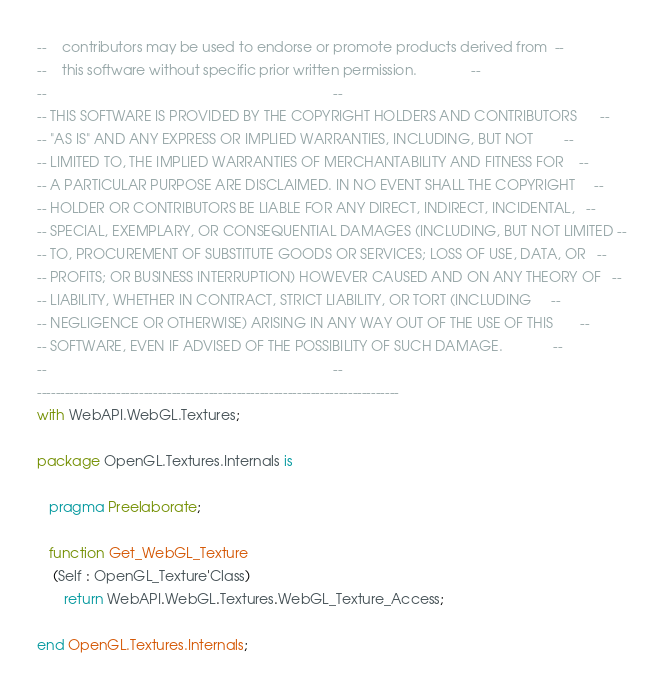Convert code to text. <code><loc_0><loc_0><loc_500><loc_500><_Ada_>--    contributors may be used to endorse or promote products derived from  --
--    this software without specific prior written permission.              --
--                                                                          --
-- THIS SOFTWARE IS PROVIDED BY THE COPYRIGHT HOLDERS AND CONTRIBUTORS      --
-- "AS IS" AND ANY EXPRESS OR IMPLIED WARRANTIES, INCLUDING, BUT NOT        --
-- LIMITED TO, THE IMPLIED WARRANTIES OF MERCHANTABILITY AND FITNESS FOR    --
-- A PARTICULAR PURPOSE ARE DISCLAIMED. IN NO EVENT SHALL THE COPYRIGHT     --
-- HOLDER OR CONTRIBUTORS BE LIABLE FOR ANY DIRECT, INDIRECT, INCIDENTAL,   --
-- SPECIAL, EXEMPLARY, OR CONSEQUENTIAL DAMAGES (INCLUDING, BUT NOT LIMITED --
-- TO, PROCUREMENT OF SUBSTITUTE GOODS OR SERVICES; LOSS OF USE, DATA, OR   --
-- PROFITS; OR BUSINESS INTERRUPTION) HOWEVER CAUSED AND ON ANY THEORY OF   --
-- LIABILITY, WHETHER IN CONTRACT, STRICT LIABILITY, OR TORT (INCLUDING     --
-- NEGLIGENCE OR OTHERWISE) ARISING IN ANY WAY OUT OF THE USE OF THIS       --
-- SOFTWARE, EVEN IF ADVISED OF THE POSSIBILITY OF SUCH DAMAGE.             --
--                                                                          --
------------------------------------------------------------------------------
with WebAPI.WebGL.Textures;

package OpenGL.Textures.Internals is

   pragma Preelaborate;

   function Get_WebGL_Texture
    (Self : OpenGL_Texture'Class)
       return WebAPI.WebGL.Textures.WebGL_Texture_Access;

end OpenGL.Textures.Internals;
</code> 